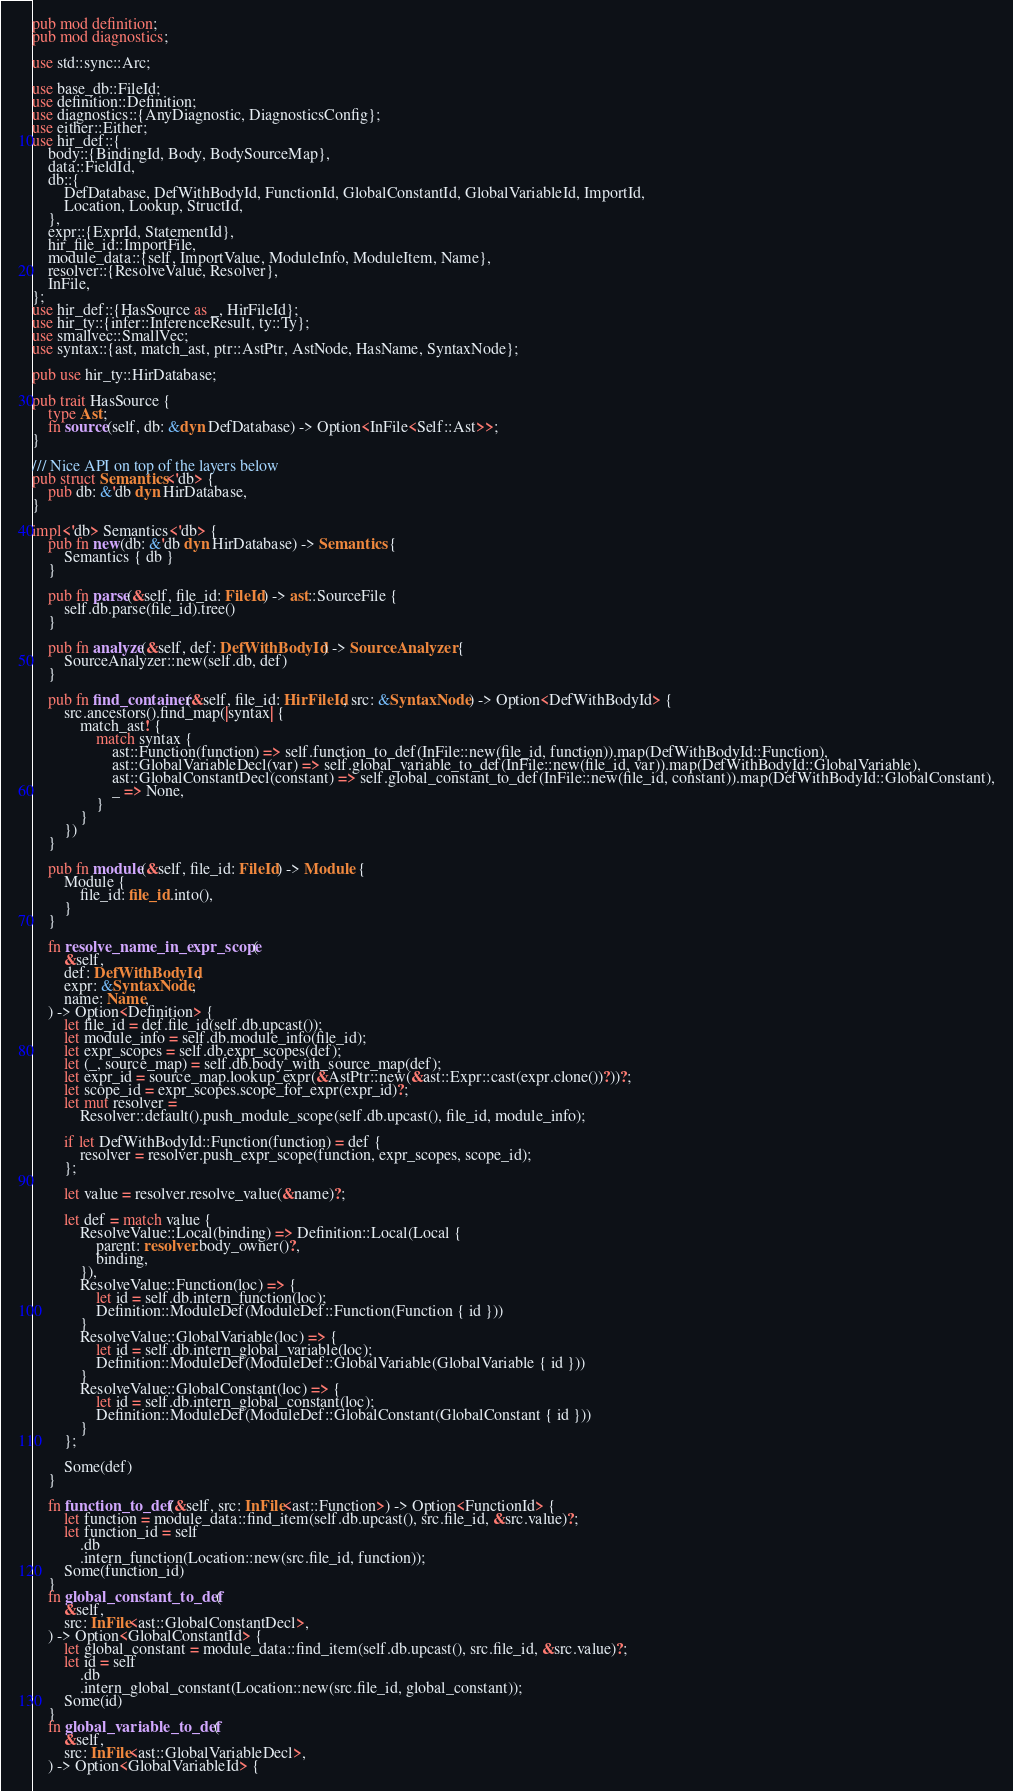Convert code to text. <code><loc_0><loc_0><loc_500><loc_500><_Rust_>pub mod definition;
pub mod diagnostics;

use std::sync::Arc;

use base_db::FileId;
use definition::Definition;
use diagnostics::{AnyDiagnostic, DiagnosticsConfig};
use either::Either;
use hir_def::{
    body::{BindingId, Body, BodySourceMap},
    data::FieldId,
    db::{
        DefDatabase, DefWithBodyId, FunctionId, GlobalConstantId, GlobalVariableId, ImportId,
        Location, Lookup, StructId,
    },
    expr::{ExprId, StatementId},
    hir_file_id::ImportFile,
    module_data::{self, ImportValue, ModuleInfo, ModuleItem, Name},
    resolver::{ResolveValue, Resolver},
    InFile,
};
use hir_def::{HasSource as _, HirFileId};
use hir_ty::{infer::InferenceResult, ty::Ty};
use smallvec::SmallVec;
use syntax::{ast, match_ast, ptr::AstPtr, AstNode, HasName, SyntaxNode};

pub use hir_ty::HirDatabase;

pub trait HasSource {
    type Ast;
    fn source(self, db: &dyn DefDatabase) -> Option<InFile<Self::Ast>>;
}

/// Nice API on top of the layers below
pub struct Semantics<'db> {
    pub db: &'db dyn HirDatabase,
}

impl<'db> Semantics<'db> {
    pub fn new(db: &'db dyn HirDatabase) -> Semantics {
        Semantics { db }
    }

    pub fn parse(&self, file_id: FileId) -> ast::SourceFile {
        self.db.parse(file_id).tree()
    }

    pub fn analyze(&self, def: DefWithBodyId) -> SourceAnalyzer {
        SourceAnalyzer::new(self.db, def)
    }

    pub fn find_container(&self, file_id: HirFileId, src: &SyntaxNode) -> Option<DefWithBodyId> {
        src.ancestors().find_map(|syntax| {
            match_ast! {
                match syntax {
                    ast::Function(function) => self.function_to_def(InFile::new(file_id, function)).map(DefWithBodyId::Function),
                    ast::GlobalVariableDecl(var) => self.global_variable_to_def(InFile::new(file_id, var)).map(DefWithBodyId::GlobalVariable),
                    ast::GlobalConstantDecl(constant) => self.global_constant_to_def(InFile::new(file_id, constant)).map(DefWithBodyId::GlobalConstant),
                    _ => None,
                }
            }
        })
    }

    pub fn module(&self, file_id: FileId) -> Module {
        Module {
            file_id: file_id.into(),
        }
    }

    fn resolve_name_in_expr_scope(
        &self,
        def: DefWithBodyId,
        expr: &SyntaxNode,
        name: Name,
    ) -> Option<Definition> {
        let file_id = def.file_id(self.db.upcast());
        let module_info = self.db.module_info(file_id);
        let expr_scopes = self.db.expr_scopes(def);
        let (_, source_map) = self.db.body_with_source_map(def);
        let expr_id = source_map.lookup_expr(&AstPtr::new(&ast::Expr::cast(expr.clone())?))?;
        let scope_id = expr_scopes.scope_for_expr(expr_id)?;
        let mut resolver =
            Resolver::default().push_module_scope(self.db.upcast(), file_id, module_info);

        if let DefWithBodyId::Function(function) = def {
            resolver = resolver.push_expr_scope(function, expr_scopes, scope_id);
        };

        let value = resolver.resolve_value(&name)?;

        let def = match value {
            ResolveValue::Local(binding) => Definition::Local(Local {
                parent: resolver.body_owner()?,
                binding,
            }),
            ResolveValue::Function(loc) => {
                let id = self.db.intern_function(loc);
                Definition::ModuleDef(ModuleDef::Function(Function { id }))
            }
            ResolveValue::GlobalVariable(loc) => {
                let id = self.db.intern_global_variable(loc);
                Definition::ModuleDef(ModuleDef::GlobalVariable(GlobalVariable { id }))
            }
            ResolveValue::GlobalConstant(loc) => {
                let id = self.db.intern_global_constant(loc);
                Definition::ModuleDef(ModuleDef::GlobalConstant(GlobalConstant { id }))
            }
        };

        Some(def)
    }

    fn function_to_def(&self, src: InFile<ast::Function>) -> Option<FunctionId> {
        let function = module_data::find_item(self.db.upcast(), src.file_id, &src.value)?;
        let function_id = self
            .db
            .intern_function(Location::new(src.file_id, function));
        Some(function_id)
    }
    fn global_constant_to_def(
        &self,
        src: InFile<ast::GlobalConstantDecl>,
    ) -> Option<GlobalConstantId> {
        let global_constant = module_data::find_item(self.db.upcast(), src.file_id, &src.value)?;
        let id = self
            .db
            .intern_global_constant(Location::new(src.file_id, global_constant));
        Some(id)
    }
    fn global_variable_to_def(
        &self,
        src: InFile<ast::GlobalVariableDecl>,
    ) -> Option<GlobalVariableId> {</code> 